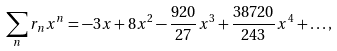<formula> <loc_0><loc_0><loc_500><loc_500>\sum _ { n } r _ { n } x ^ { n } = - 3 x + 8 x ^ { 2 } - \frac { 9 2 0 } { 2 7 } x ^ { 3 } + \frac { 3 8 7 2 0 } { 2 4 3 } x ^ { 4 } + \dots ,</formula> 